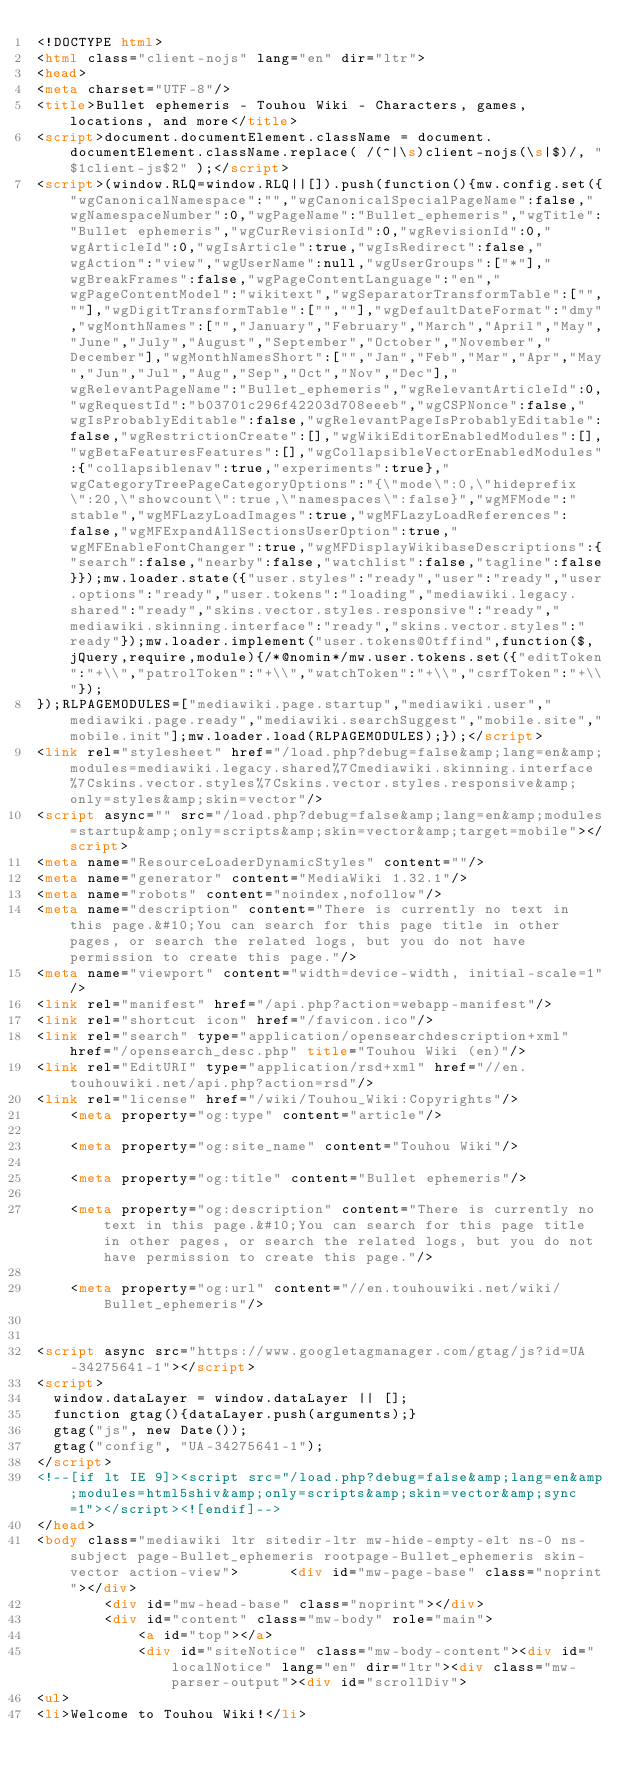Convert code to text. <code><loc_0><loc_0><loc_500><loc_500><_HTML_><!DOCTYPE html>
<html class="client-nojs" lang="en" dir="ltr">
<head>
<meta charset="UTF-8"/>
<title>Bullet ephemeris - Touhou Wiki - Characters, games, locations, and more</title>
<script>document.documentElement.className = document.documentElement.className.replace( /(^|\s)client-nojs(\s|$)/, "$1client-js$2" );</script>
<script>(window.RLQ=window.RLQ||[]).push(function(){mw.config.set({"wgCanonicalNamespace":"","wgCanonicalSpecialPageName":false,"wgNamespaceNumber":0,"wgPageName":"Bullet_ephemeris","wgTitle":"Bullet ephemeris","wgCurRevisionId":0,"wgRevisionId":0,"wgArticleId":0,"wgIsArticle":true,"wgIsRedirect":false,"wgAction":"view","wgUserName":null,"wgUserGroups":["*"],"wgBreakFrames":false,"wgPageContentLanguage":"en","wgPageContentModel":"wikitext","wgSeparatorTransformTable":["",""],"wgDigitTransformTable":["",""],"wgDefaultDateFormat":"dmy","wgMonthNames":["","January","February","March","April","May","June","July","August","September","October","November","December"],"wgMonthNamesShort":["","Jan","Feb","Mar","Apr","May","Jun","Jul","Aug","Sep","Oct","Nov","Dec"],"wgRelevantPageName":"Bullet_ephemeris","wgRelevantArticleId":0,"wgRequestId":"b03701c296f42203d708eeeb","wgCSPNonce":false,"wgIsProbablyEditable":false,"wgRelevantPageIsProbablyEditable":false,"wgRestrictionCreate":[],"wgWikiEditorEnabledModules":[],"wgBetaFeaturesFeatures":[],"wgCollapsibleVectorEnabledModules":{"collapsiblenav":true,"experiments":true},"wgCategoryTreePageCategoryOptions":"{\"mode\":0,\"hideprefix\":20,\"showcount\":true,\"namespaces\":false}","wgMFMode":"stable","wgMFLazyLoadImages":true,"wgMFLazyLoadReferences":false,"wgMFExpandAllSectionsUserOption":true,"wgMFEnableFontChanger":true,"wgMFDisplayWikibaseDescriptions":{"search":false,"nearby":false,"watchlist":false,"tagline":false}});mw.loader.state({"user.styles":"ready","user":"ready","user.options":"ready","user.tokens":"loading","mediawiki.legacy.shared":"ready","skins.vector.styles.responsive":"ready","mediawiki.skinning.interface":"ready","skins.vector.styles":"ready"});mw.loader.implement("user.tokens@0tffind",function($,jQuery,require,module){/*@nomin*/mw.user.tokens.set({"editToken":"+\\","patrolToken":"+\\","watchToken":"+\\","csrfToken":"+\\"});
});RLPAGEMODULES=["mediawiki.page.startup","mediawiki.user","mediawiki.page.ready","mediawiki.searchSuggest","mobile.site","mobile.init"];mw.loader.load(RLPAGEMODULES);});</script>
<link rel="stylesheet" href="/load.php?debug=false&amp;lang=en&amp;modules=mediawiki.legacy.shared%7Cmediawiki.skinning.interface%7Cskins.vector.styles%7Cskins.vector.styles.responsive&amp;only=styles&amp;skin=vector"/>
<script async="" src="/load.php?debug=false&amp;lang=en&amp;modules=startup&amp;only=scripts&amp;skin=vector&amp;target=mobile"></script>
<meta name="ResourceLoaderDynamicStyles" content=""/>
<meta name="generator" content="MediaWiki 1.32.1"/>
<meta name="robots" content="noindex,nofollow"/>
<meta name="description" content="There is currently no text in this page.&#10;You can search for this page title in other pages, or search the related logs, but you do not have permission to create this page."/>
<meta name="viewport" content="width=device-width, initial-scale=1"/>
<link rel="manifest" href="/api.php?action=webapp-manifest"/>
<link rel="shortcut icon" href="/favicon.ico"/>
<link rel="search" type="application/opensearchdescription+xml" href="/opensearch_desc.php" title="Touhou Wiki (en)"/>
<link rel="EditURI" type="application/rsd+xml" href="//en.touhouwiki.net/api.php?action=rsd"/>
<link rel="license" href="/wiki/Touhou_Wiki:Copyrights"/>
	<meta property="og:type" content="article"/>

	<meta property="og:site_name" content="Touhou Wiki"/>

	<meta property="og:title" content="Bullet ephemeris"/>

	<meta property="og:description" content="There is currently no text in this page.&#10;You can search for this page title in other pages, or search the related logs, but you do not have permission to create this page."/>

	<meta property="og:url" content="//en.touhouwiki.net/wiki/Bullet_ephemeris"/>


<script async src="https://www.googletagmanager.com/gtag/js?id=UA-34275641-1"></script>
<script>
  window.dataLayer = window.dataLayer || [];
  function gtag(){dataLayer.push(arguments);}
  gtag("js", new Date());
  gtag("config", "UA-34275641-1");
</script>
<!--[if lt IE 9]><script src="/load.php?debug=false&amp;lang=en&amp;modules=html5shiv&amp;only=scripts&amp;skin=vector&amp;sync=1"></script><![endif]-->
</head>
<body class="mediawiki ltr sitedir-ltr mw-hide-empty-elt ns-0 ns-subject page-Bullet_ephemeris rootpage-Bullet_ephemeris skin-vector action-view">		<div id="mw-page-base" class="noprint"></div>
		<div id="mw-head-base" class="noprint"></div>
		<div id="content" class="mw-body" role="main">
			<a id="top"></a>
			<div id="siteNotice" class="mw-body-content"><div id="localNotice" lang="en" dir="ltr"><div class="mw-parser-output"><div id="scrollDiv">
<ul>
<li>Welcome to Touhou Wiki!</li></code> 